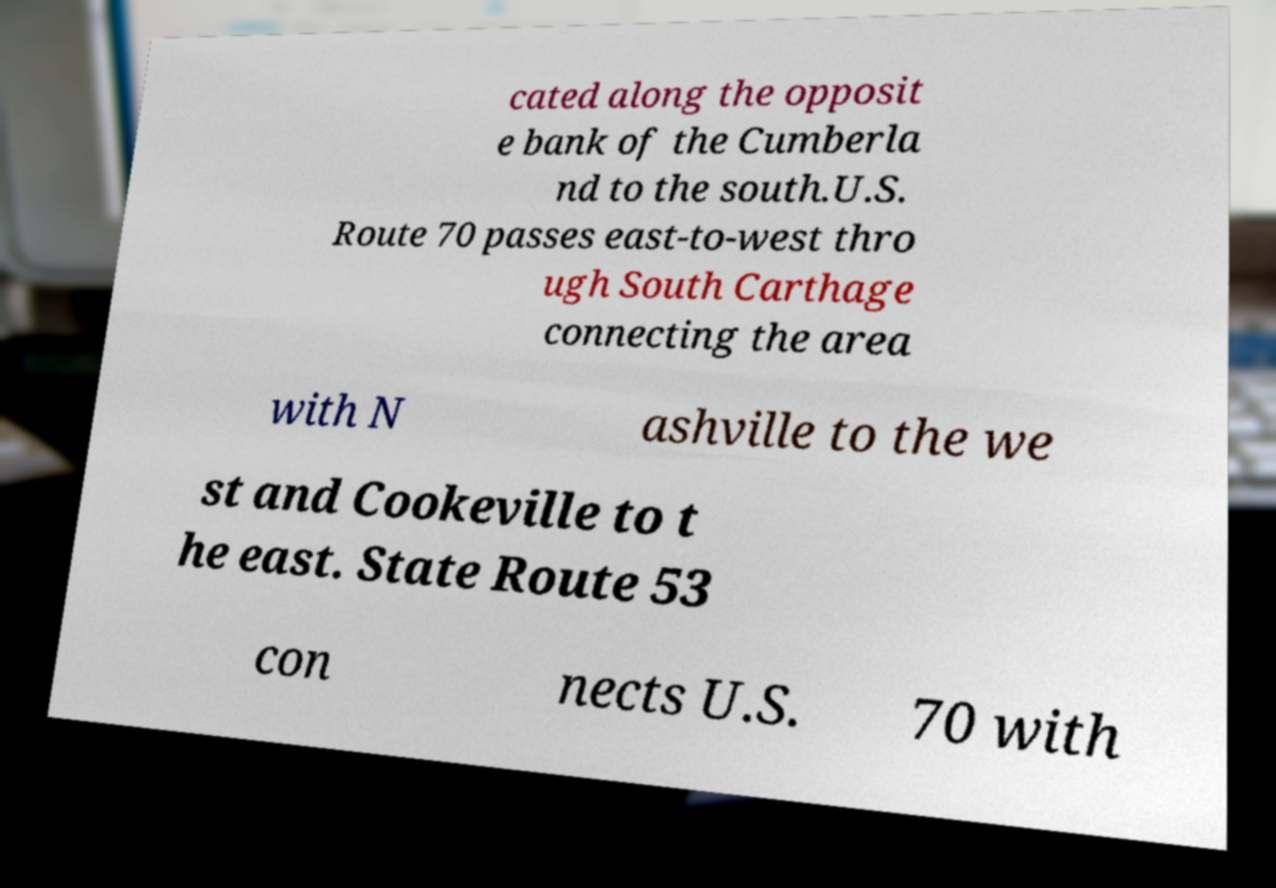What messages or text are displayed in this image? I need them in a readable, typed format. cated along the opposit e bank of the Cumberla nd to the south.U.S. Route 70 passes east-to-west thro ugh South Carthage connecting the area with N ashville to the we st and Cookeville to t he east. State Route 53 con nects U.S. 70 with 